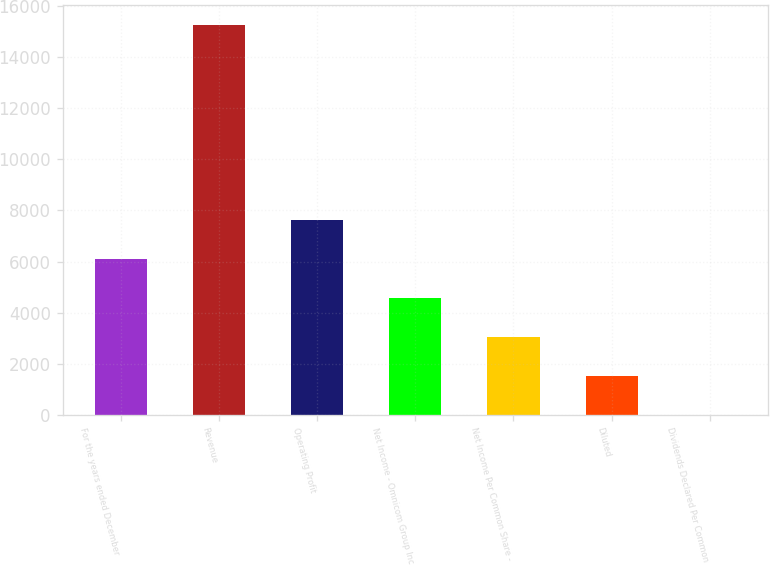Convert chart to OTSL. <chart><loc_0><loc_0><loc_500><loc_500><bar_chart><fcel>For the years ended December<fcel>Revenue<fcel>Operating Profit<fcel>Net Income - Omnicom Group Inc<fcel>Net Income Per Common Share -<fcel>Diluted<fcel>Dividends Declared Per Common<nl><fcel>6110.81<fcel>15273.6<fcel>7637.95<fcel>4583.67<fcel>3056.53<fcel>1529.39<fcel>2.25<nl></chart> 